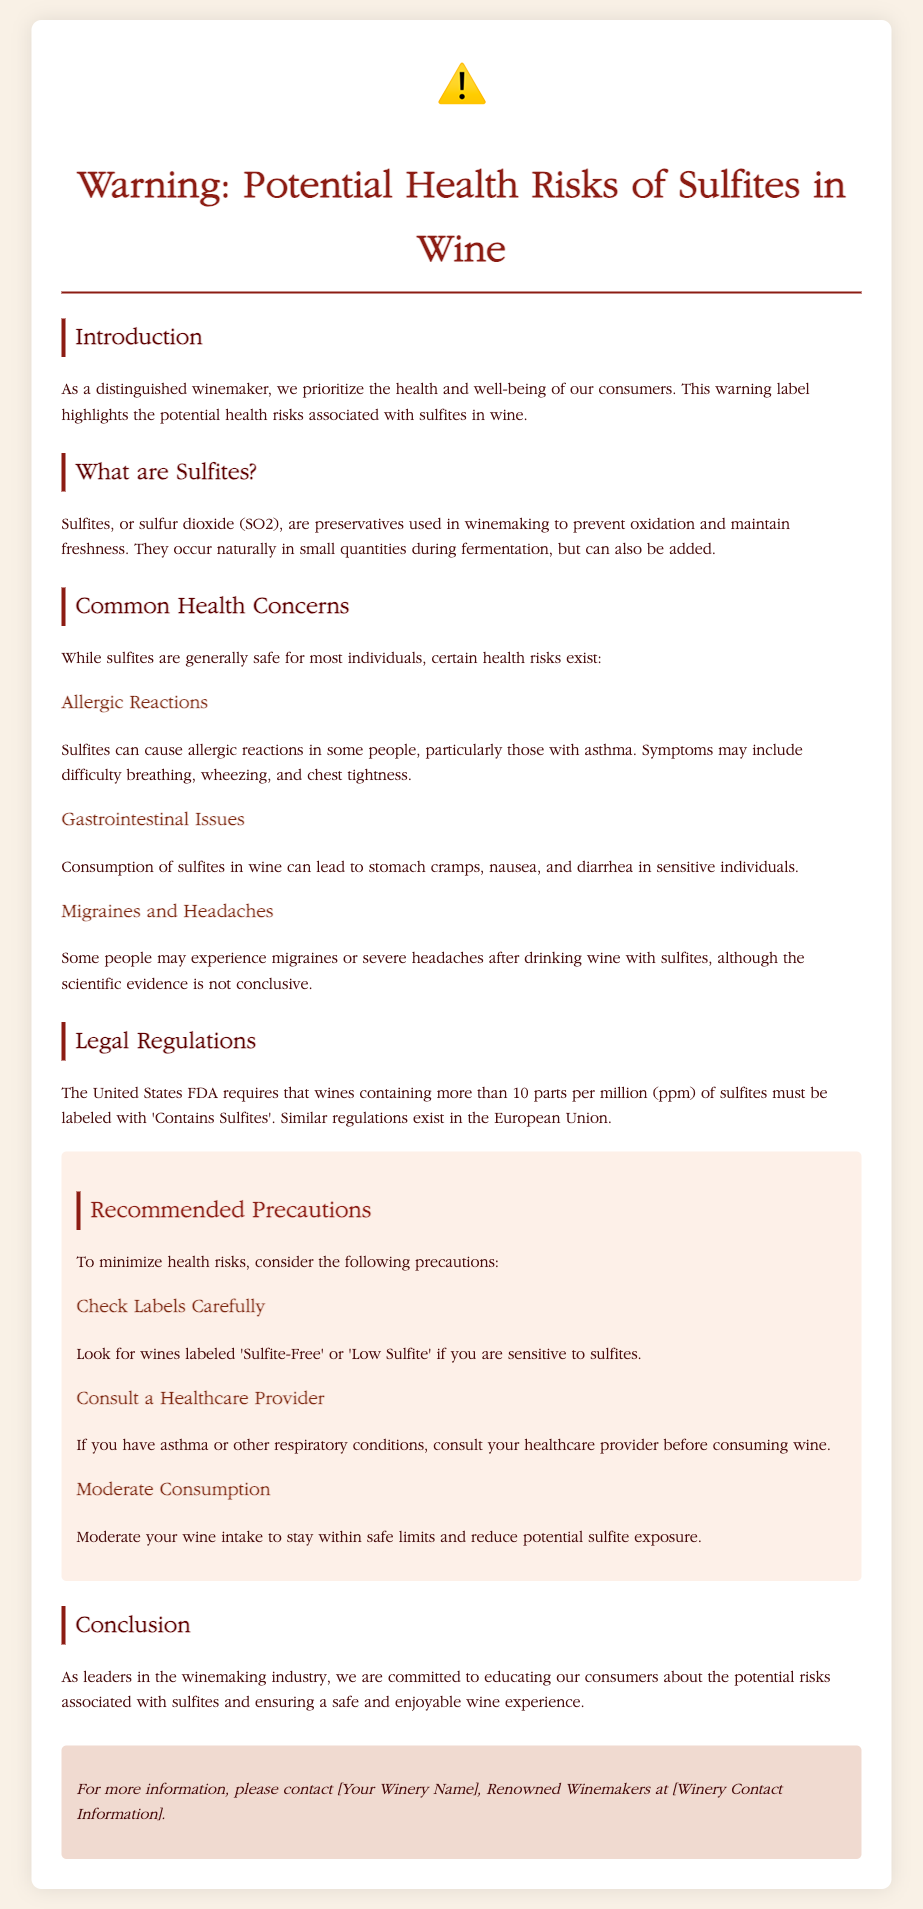What are sulfites? Sulfites are preservatives used in winemaking to prevent oxidation and maintain freshness.
Answer: Preservatives used in winemaking What symptoms may indicate an allergic reaction to sulfites? Symptoms of allergic reactions to sulfites may include difficulty breathing, wheezing, and chest tightness.
Answer: Difficulty breathing, wheezing, chest tightness What is the legal requirement for labeling sulfites in the US? The US FDA requires that wines containing more than 10 parts per million of sulfites must be labeled with 'Contains Sulfites'.
Answer: 'Contains Sulfites' What precautions are recommended for wine consumption? Recommendations include checking labels carefully, consulting a healthcare provider, and moderating consumption.
Answer: Check labels, consult provider, moderate consumption What is a common gastrointestinal issue related to sulfites? Consumption of sulfites can lead to stomach cramps, nausea, and diarrhea in sensitive individuals.
Answer: Stomach cramps, nausea, diarrhea What action should individuals with asthma take regarding wine consumption? Individuals with asthma should consult their healthcare provider before consuming wine.
Answer: Consult healthcare provider How many parts per million of sulfites is the labeling threshold? The labeling threshold for sulfites is 10 parts per million in the US.
Answer: 10 parts per million What is the focus of this warning label? The warning label highlights the potential health risks associated with sulfites in wine.
Answer: Potential health risks of sulfites in wine 